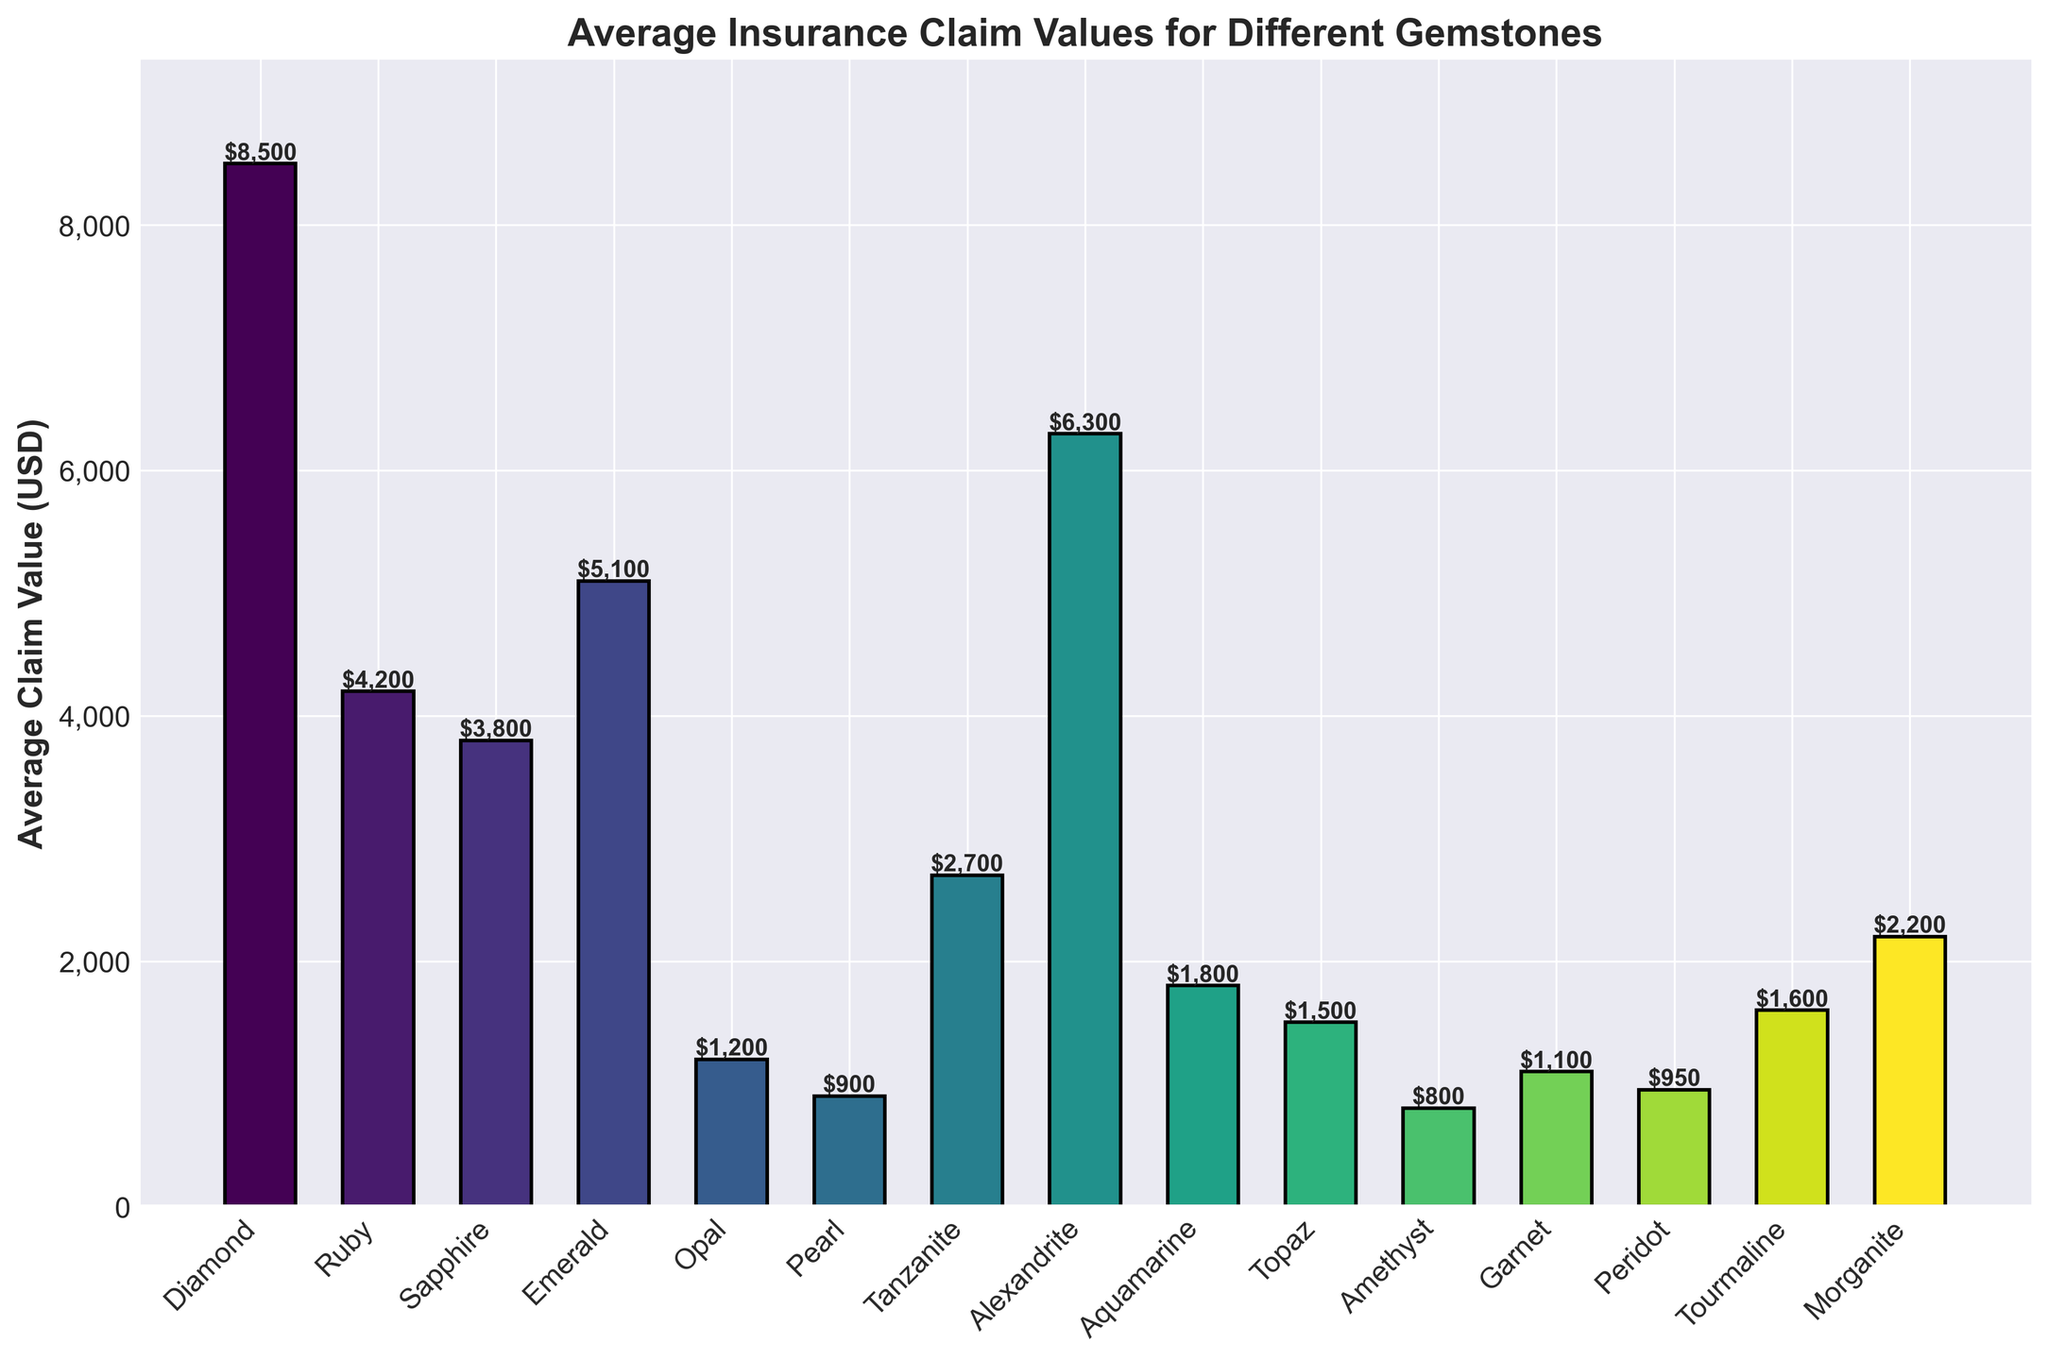What is the highest average insurance claim value among the gemstones? The highest average claim value can be identified as the tallest bar in the bar chart.
Answer: Diamond ($8,500) What is the difference in average claim value between Diamond and Emerald? To find the difference, subtract the average claim value of Emerald from that of Diamond: $8,500 - $5,100.
Answer: $3,400 Which gemstone has the lowest average insurance claim value and what is it? The gemstone with the lowest claim value is represented by the shortest bar in the chart.
Answer: Amethyst ($800) How many gemstones have an average claim value greater than $5,000? Identify and count the bars that have a height corresponding to values greater than $5,000.
Answer: 3 (Diamond, Alexandrite, Emerald) What is the combined average claim value for Pearl, Opal, and Topaz? Sum the average claim values of Pearl, Opal, and Topaz: $900 (Pearl) + $1,200 (Opal) + $1,500 (Topaz).
Answer: $3,600 Between Tourmaline and Morganite, which gemstone has a higher average insurance claim value? Compare the heights of the bars representing Tourmaline and Morganite.
Answer: Morganite ($2,200) By how much does the average claim value of Ruby exceed that of Sapphire? Subtract the average claim value of Sapphire from that of Ruby: $4,200 - $3,800.
Answer: $400 Which three gemstones have the closest average insurance claim values? Identify the bars with the most similar heights or close average values.
Answer: Sapphire ($3,800), Ruby ($4,200), Tanzanite ($2,700) What is the average of the claim values for Diamond, Ruby, and Sapphire? Add the average claim values and divide by the number of gemstones: ($8,500 + $4,200 + $3,800) / 3.
Answer: $5,500 Rank the gemstones by their average claim values in descending order. Order the gemstones based on the height of their respective bars from tallest to shortest.
Answer: Diamond, Alexandrite, Emerald, Ruby, Sapphire, Tanzanite, Morganite, Aquamarine, Tourmaline, Topaz, Opal, Garnet, Peridot, Pearl, Amethyst 